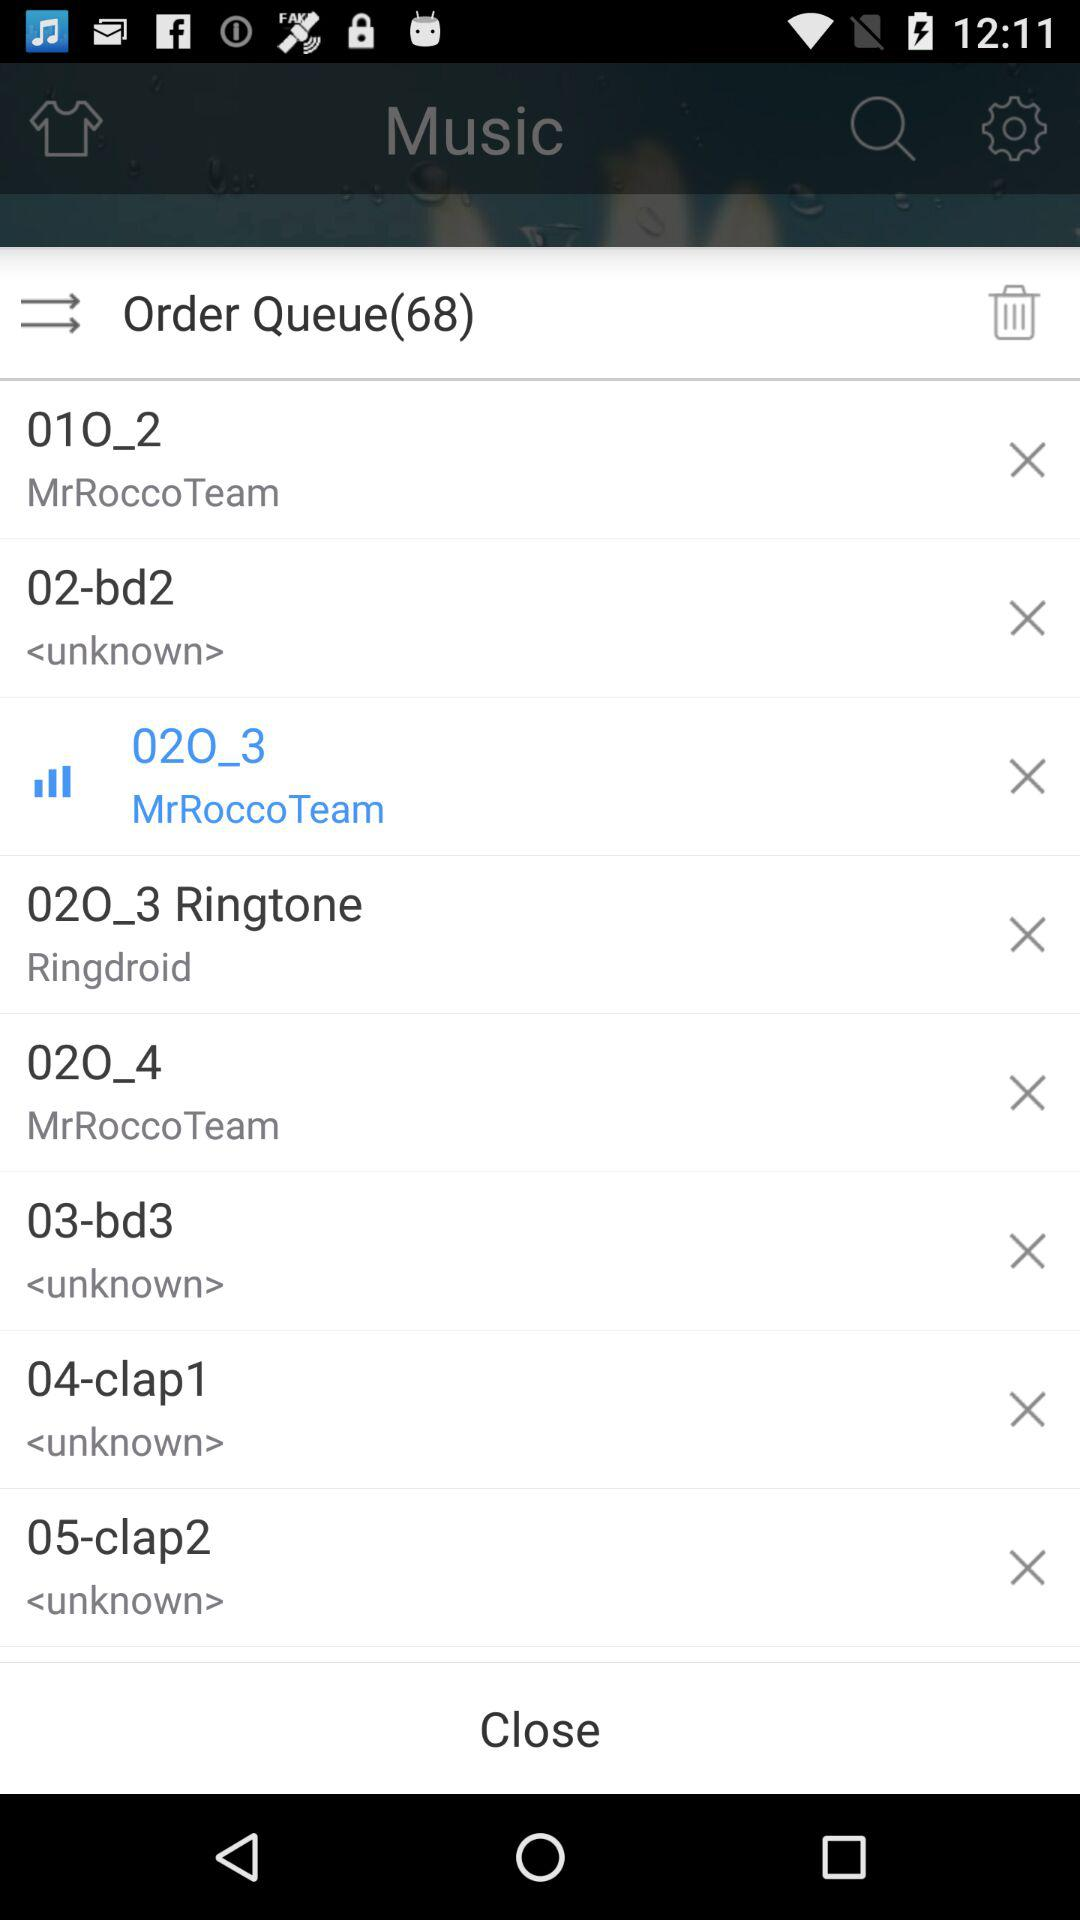How many items are in the order queue?
Answer the question using a single word or phrase. 68 